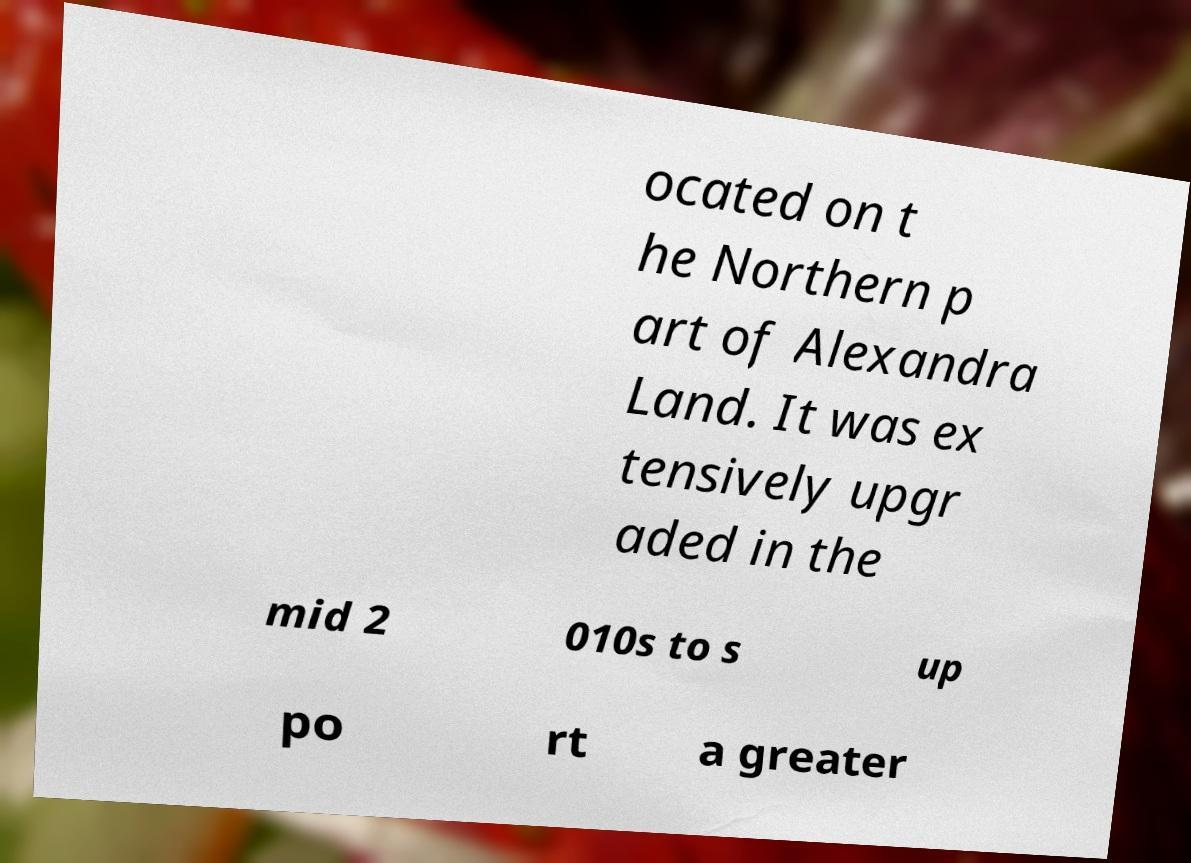I need the written content from this picture converted into text. Can you do that? ocated on t he Northern p art of Alexandra Land. It was ex tensively upgr aded in the mid 2 010s to s up po rt a greater 